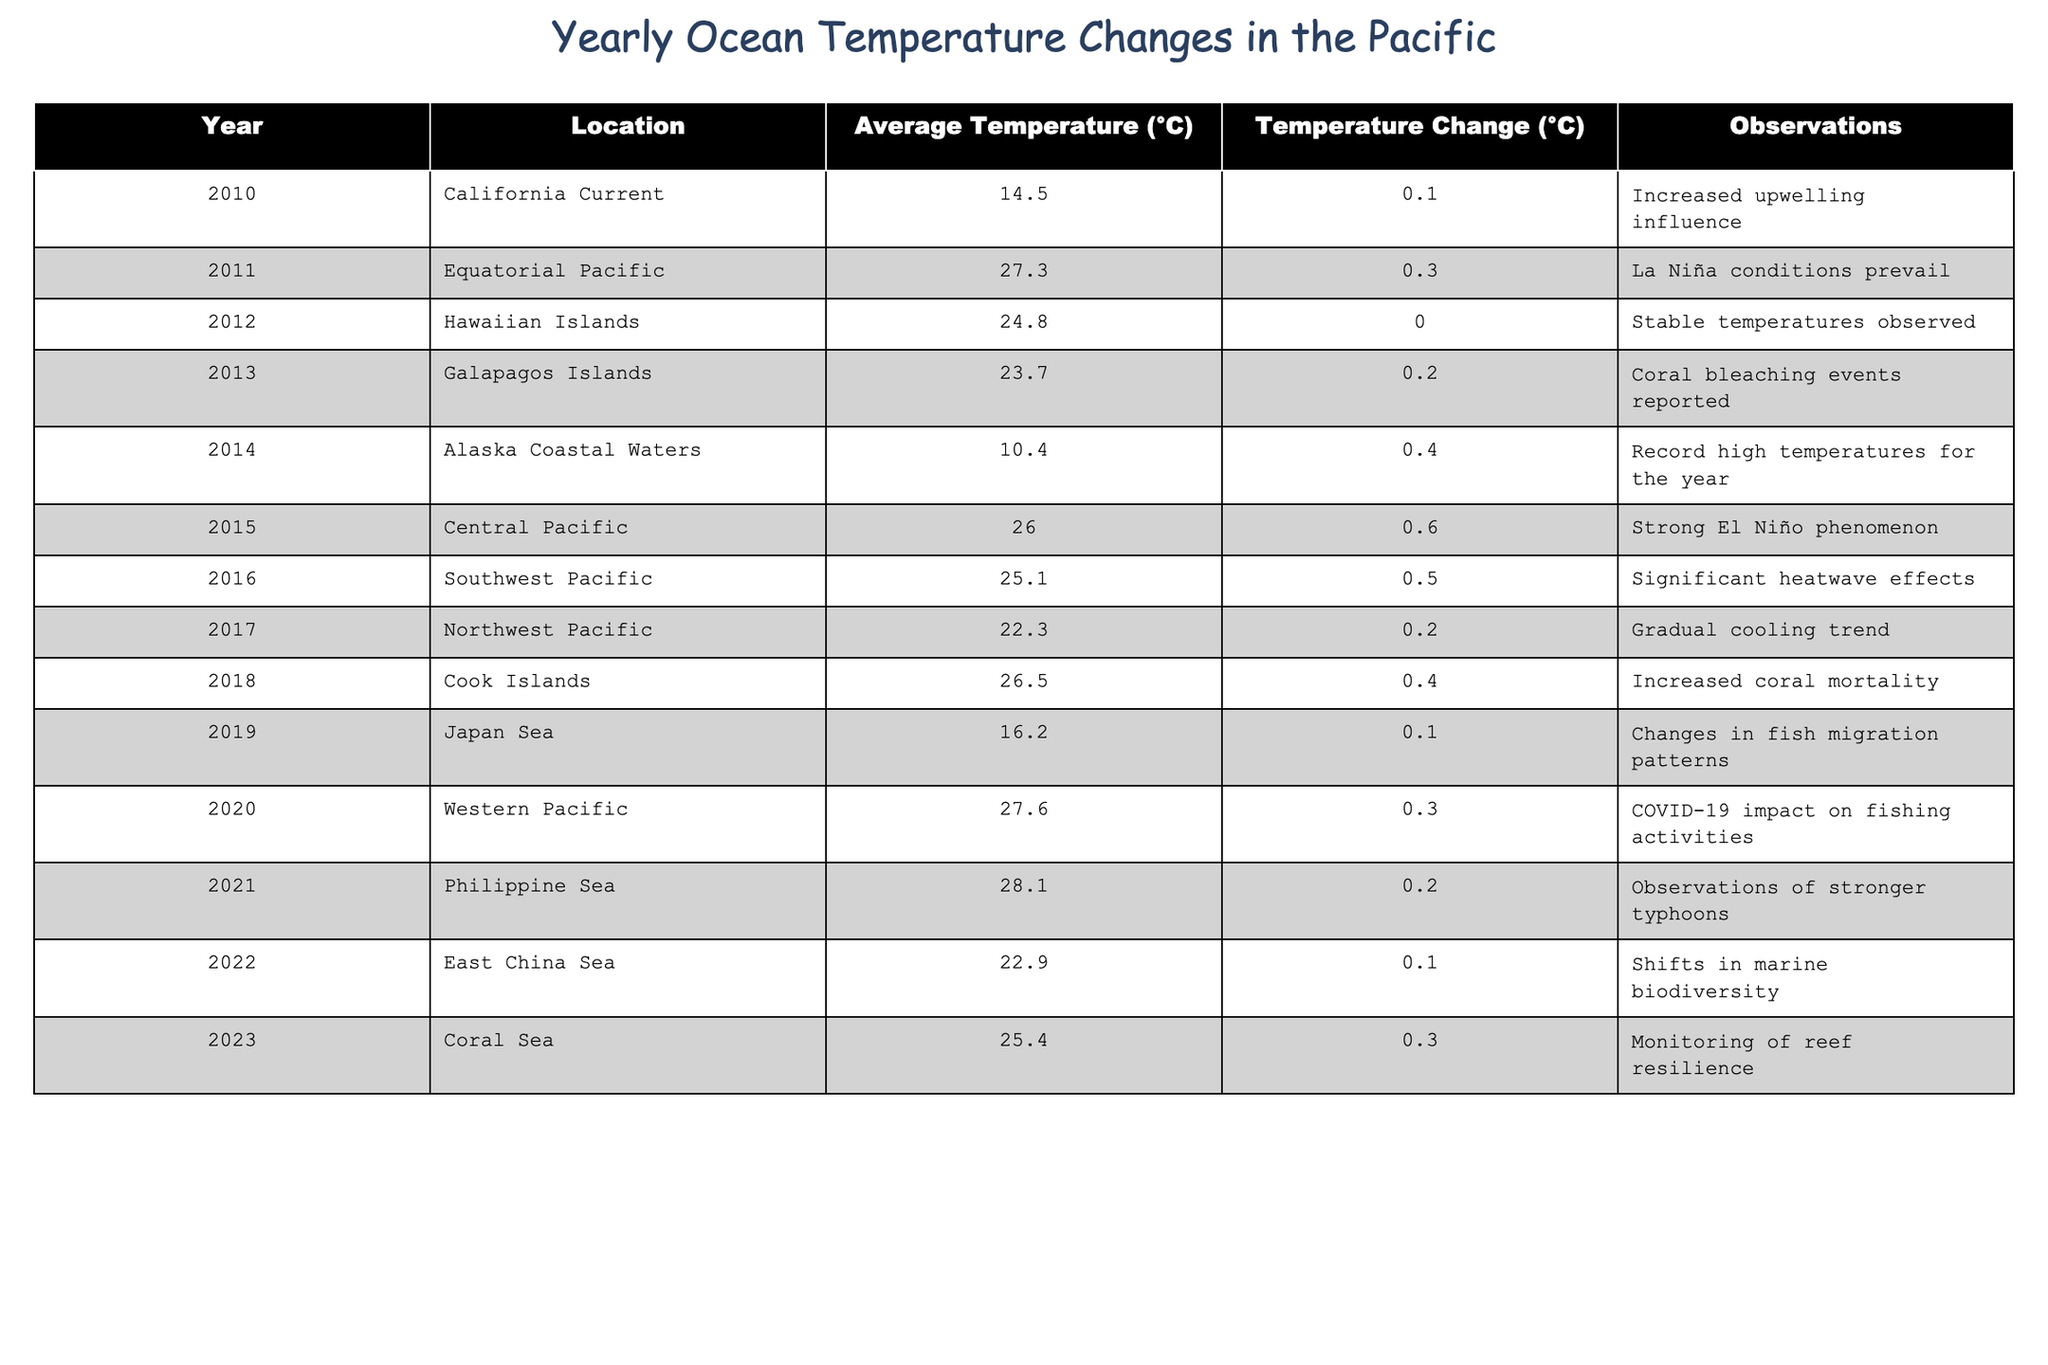What was the average temperature recorded in the Galapagos Islands in 2013? According to the table, the average temperature in the Galapagos Islands in 2013 is 23.7°C.
Answer: 23.7°C In which year did the Central Pacific experience the highest temperature change? The Central Pacific's temperature change is noted as 0.6°C in 2015, which is the highest change recorded in the table.
Answer: 2015 What is the temperature change recorded in the Philippine Sea in 2021? The table indicates a temperature change of 0.2°C in the Philippine Sea for the year 2021.
Answer: 0.2°C Which location had the lowest average temperature and what was it? Alaska Coastal Waters had the lowest average temperature, recorded at 10.4°C in 2014.
Answer: 10.4°C Is it true that the temperature in the Equatorial Pacific in 2011 was higher than the average temperature in the Coral Sea in 2023? Yes, the average temperature in the Equatorial Pacific in 2011 was 27.3°C, while the temperature in the Coral Sea in 2023 was 25.4°C.
Answer: Yes What were the average temperatures in the California Current in 2010 and the Cook Islands in 2018, and what is the difference between them? The California Current's average temperature in 2010 was 14.5°C, and the Cook Islands' temperature in 2018 was 26.5°C. The difference is calculated as 26.5°C - 14.5°C = 12.0°C.
Answer: 12.0°C How many years recorded a temperature change of 0.3°C or more? Looking through the table, the years with a 0.3°C or more temperature change are 2011, 2014, 2015, 2016, 2018, and 2020. That's a total of 6 years.
Answer: 6 years What is the sum of the average temperatures recorded in the Hawaiian Islands and the Japan Sea? The average temperature in the Hawaiian Islands in 2012 is 24.8°C, and in the Japan Sea in 2019 is 16.2°C. Summing these gives 24.8°C + 16.2°C = 41.0°C.
Answer: 41.0°C Which year had the highest recorded average temperature and what was it? In the table, the highest average temperature is recorded at 28.1°C in the Philippine Sea in 2021.
Answer: 28.1°C Was there any increase in the average temperature in the Coral Sea compared to the previous year? Yes, the average temperature in the Coral Sea in 2023 is 25.4°C, which is an increase compared to the previous year (2022), where it was lower.
Answer: Yes 